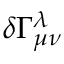Convert formula to latex. <formula><loc_0><loc_0><loc_500><loc_500>\delta \Gamma _ { \mu \nu } ^ { \lambda }</formula> 